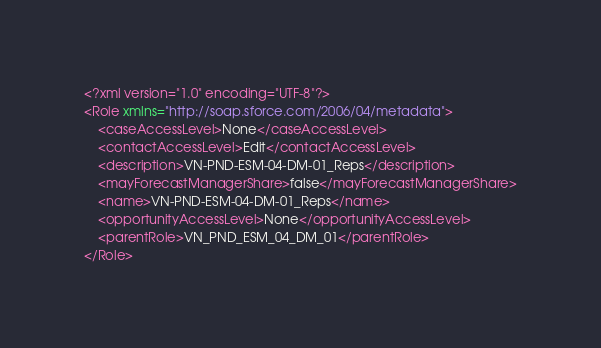<code> <loc_0><loc_0><loc_500><loc_500><_XML_><?xml version="1.0" encoding="UTF-8"?>
<Role xmlns="http://soap.sforce.com/2006/04/metadata">
    <caseAccessLevel>None</caseAccessLevel>
    <contactAccessLevel>Edit</contactAccessLevel>
    <description>VN-PND-ESM-04-DM-01_Reps</description>
    <mayForecastManagerShare>false</mayForecastManagerShare>
    <name>VN-PND-ESM-04-DM-01_Reps</name>
    <opportunityAccessLevel>None</opportunityAccessLevel>
    <parentRole>VN_PND_ESM_04_DM_01</parentRole>
</Role>
</code> 